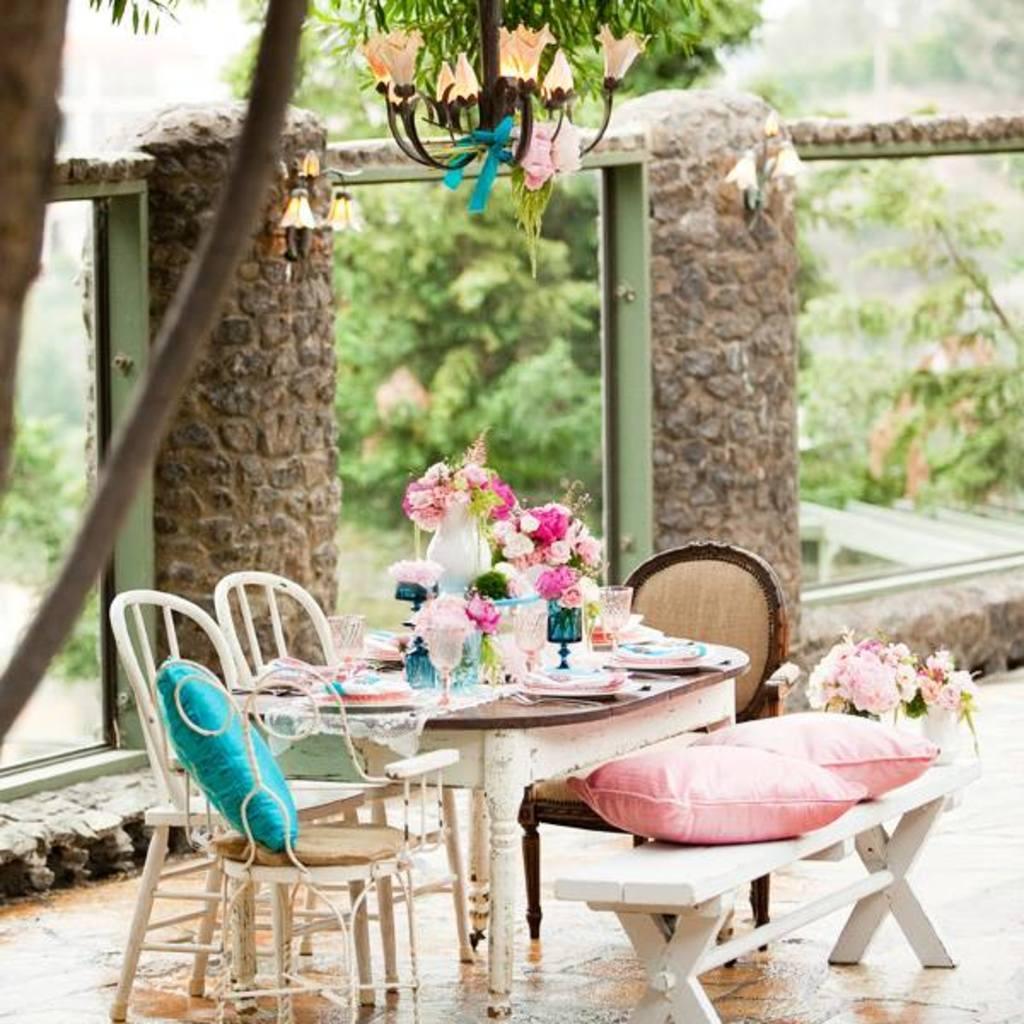Can you describe this image briefly? In the picture we can find three chairs and one bench and one table full of flowers, plates and tissues. In the background we can find the wall and lamp connected to tree and some trees are behind the wall. 